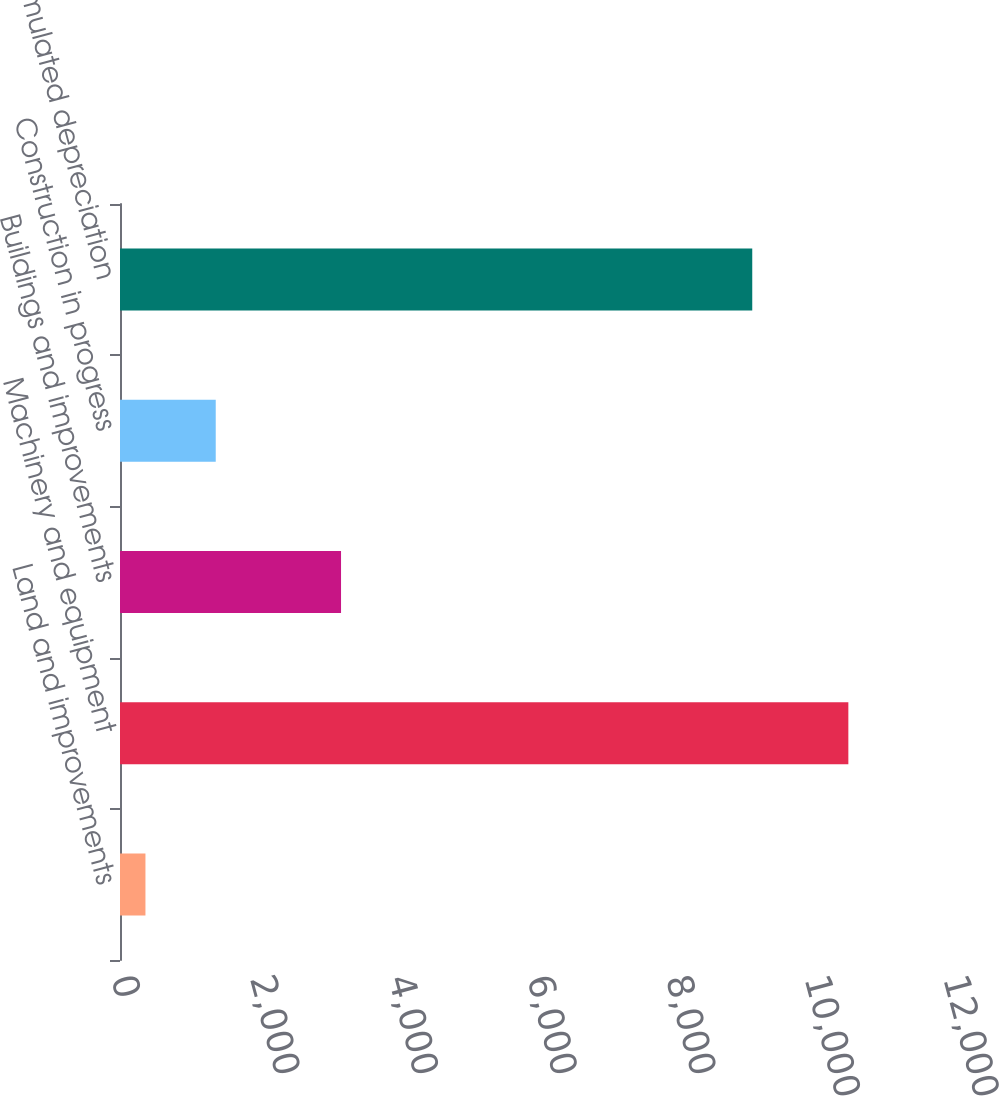Convert chart to OTSL. <chart><loc_0><loc_0><loc_500><loc_500><bar_chart><fcel>Land and improvements<fcel>Machinery and equipment<fcel>Buildings and improvements<fcel>Construction in progress<fcel>Less-Accumulated depreciation<nl><fcel>367<fcel>10505<fcel>3188<fcel>1380.8<fcel>9119<nl></chart> 